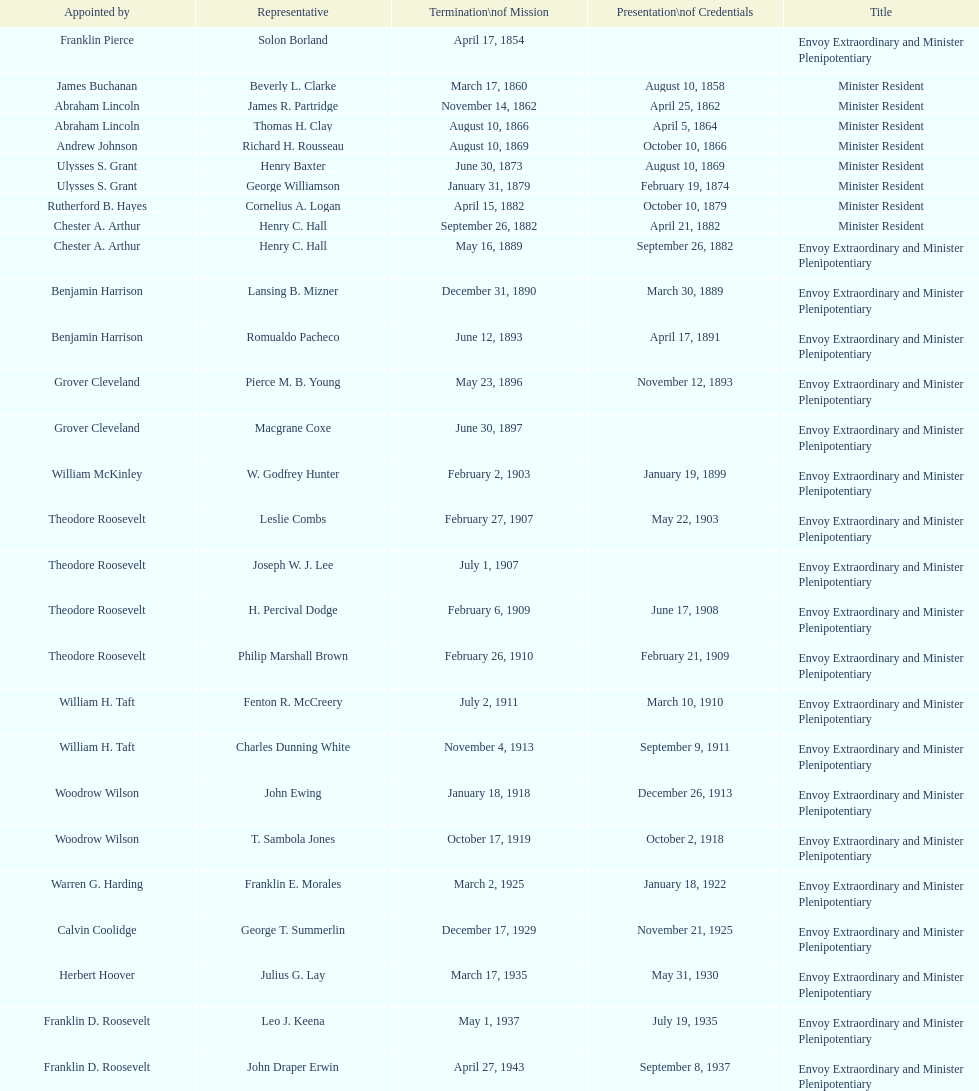How many total representatives have there been? 50. 